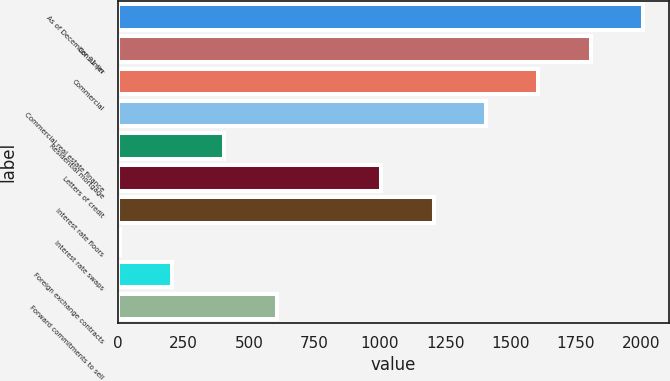Convert chart. <chart><loc_0><loc_0><loc_500><loc_500><bar_chart><fcel>As of December 31 (in<fcel>Consumer<fcel>Commercial<fcel>Commercial real estate finance<fcel>Residential mortgage<fcel>Letters of credit<fcel>Interest rate floors<fcel>Interest rate swaps<fcel>Foreign exchange contracts<fcel>Forward commitments to sell<nl><fcel>2006<fcel>1806.09<fcel>1606.18<fcel>1406.27<fcel>406.72<fcel>1006.45<fcel>1206.36<fcel>6.9<fcel>206.81<fcel>606.63<nl></chart> 